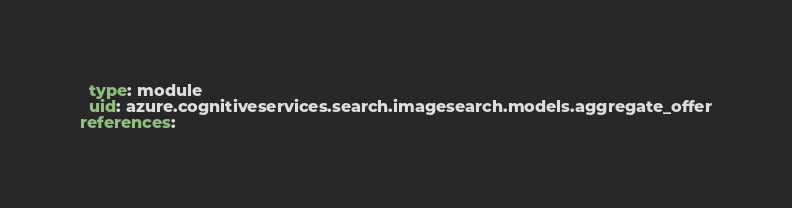<code> <loc_0><loc_0><loc_500><loc_500><_YAML_>  type: module
  uid: azure.cognitiveservices.search.imagesearch.models.aggregate_offer
references:</code> 